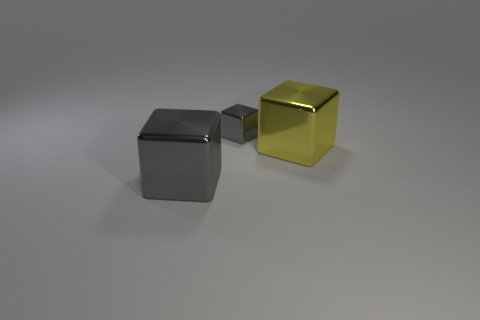Are there more small gray objects in front of the tiny gray metal cube than tiny gray objects?
Provide a succinct answer. No. How many objects are either shiny things left of the big yellow block or gray blocks that are in front of the yellow shiny thing?
Offer a terse response. 2. There is a yellow block that is made of the same material as the small gray thing; what size is it?
Keep it short and to the point. Large. Do the gray metallic object to the left of the small shiny cube and the yellow object have the same shape?
Ensure brevity in your answer.  Yes. What size is the metal object that is the same color as the tiny cube?
Your answer should be compact. Large. How many red objects are large blocks or metal objects?
Provide a succinct answer. 0. How many other objects are there of the same shape as the big gray shiny thing?
Offer a terse response. 2. There is a thing that is both right of the large gray block and on the left side of the big yellow block; what is its shape?
Provide a short and direct response. Cube. There is a large yellow thing; are there any yellow objects to the right of it?
Provide a succinct answer. No. The other yellow shiny thing that is the same shape as the tiny object is what size?
Your answer should be compact. Large. 